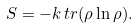<formula> <loc_0><loc_0><loc_500><loc_500>S = - k \, t r ( \rho \ln \rho ) .</formula> 